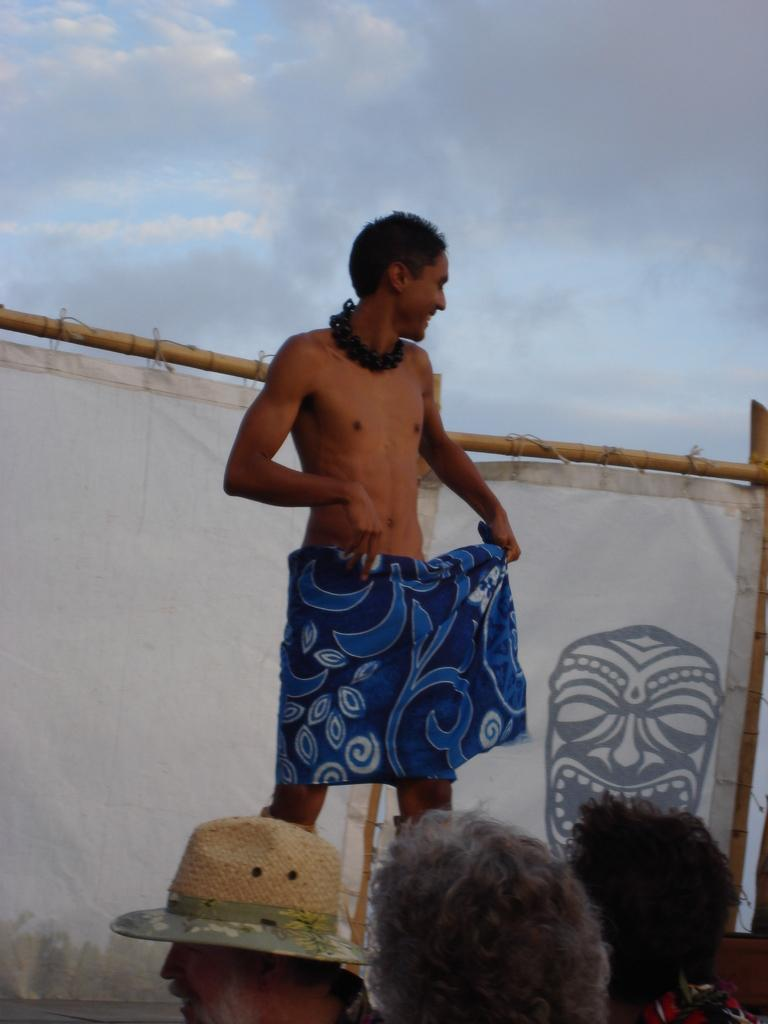What is the main subject of the image? The main subject of the image is a group of people. Can you describe one person in the group? Yes, a man is standing and smiling in the image. What can be seen in the background of the image? The sky is visible in the background of the image. What is the condition of the sky in the image? Clouds are present in the sky. What type of card is the man holding in the image? There is no card present in the image; the man is simply standing and smiling. Can you tell me how many pets are visible in the image? There are no pets visible in the image; it features a group of people and a sky with clouds. 